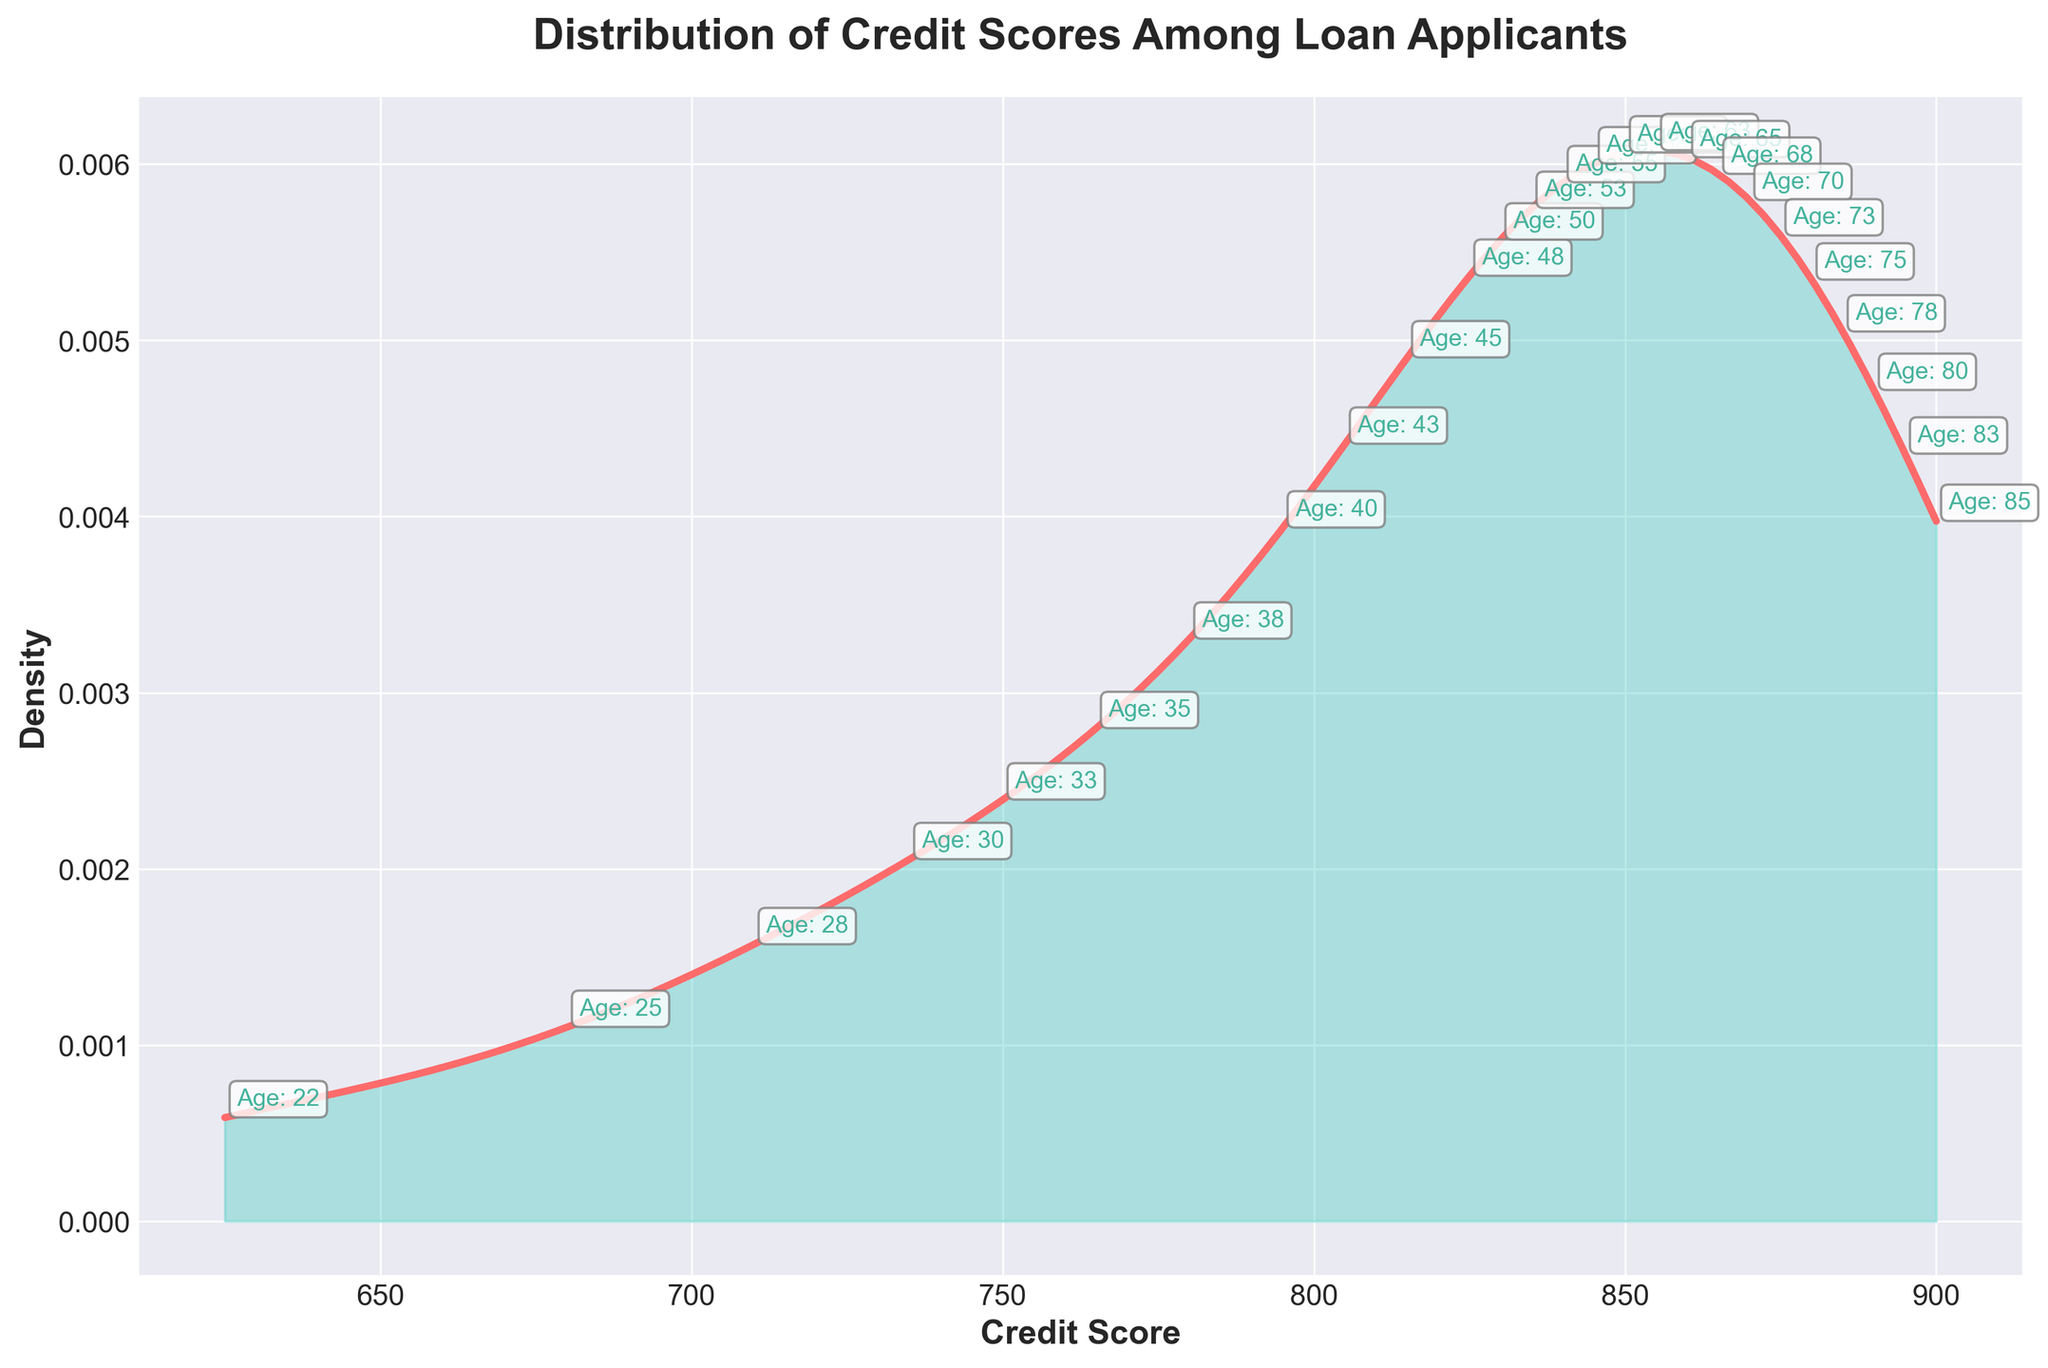What is the title of the plot? The title of the plot is usually located at the top of the figure. We can read it directly from the visual information.
Answer: Distribution of Credit Scores Among Loan Applicants What do the x-axis and y-axis represent? We can look at the labels on the x-axis and y-axis to determine what they represent. The labels are typically descriptive of the data plotted.
Answer: Credit Score, Density What color is the density plot line? By observing the plot line, we note the color used for the density plot. This color can also indicate a specific aspect or emphasis of the plot.
Answer: Red What is the range of the credit scores shown in the plot? The range of credit scores can be determined by looking at the x-axis, which shows the minimum and maximum values of the credit scores in the dataset.
Answer: 625 to 900 How does the density vary with credit scores? The density variation can be determined by observing the shape of the density curve. Peaks and troughs indicate areas of high and low densities, respectively.
Answer: The density starts low, peaks around 850, and then decreases Around which credit score value is the highest density located? The highest density can be identified by finding the peak of the density curve on the plot.
Answer: 850 How does the density of credit scores compare between the low end (625) and the high end (900)? By comparing the heights of the density curve at the extreme ends of the x-axis, we can infer how density changes from the lowest to the highest credit score.
Answer: The density is lower at both ends, with a higher density in the mid-range around 850 What is the age group of applicants with a credit score of 735? Each credit score is annotated with the corresponding age group. We can locate the annotation for a credit score of 735 and read the age group.
Answer: 30 Do older applicants generally have higher credit scores based on the annotations? By examining the annotations and comparing the ages and their corresponding credit scores, we can determine if there's a trend with age and credit scores.
Answer: Yes Is the distribution of credit scores skewed in any direction? By examining the shape of the density plot, we can determine if the distribution is skewed. For instance, whether the tail on one side is longer than the other.
Answer: Yes, slightly right-skewed 